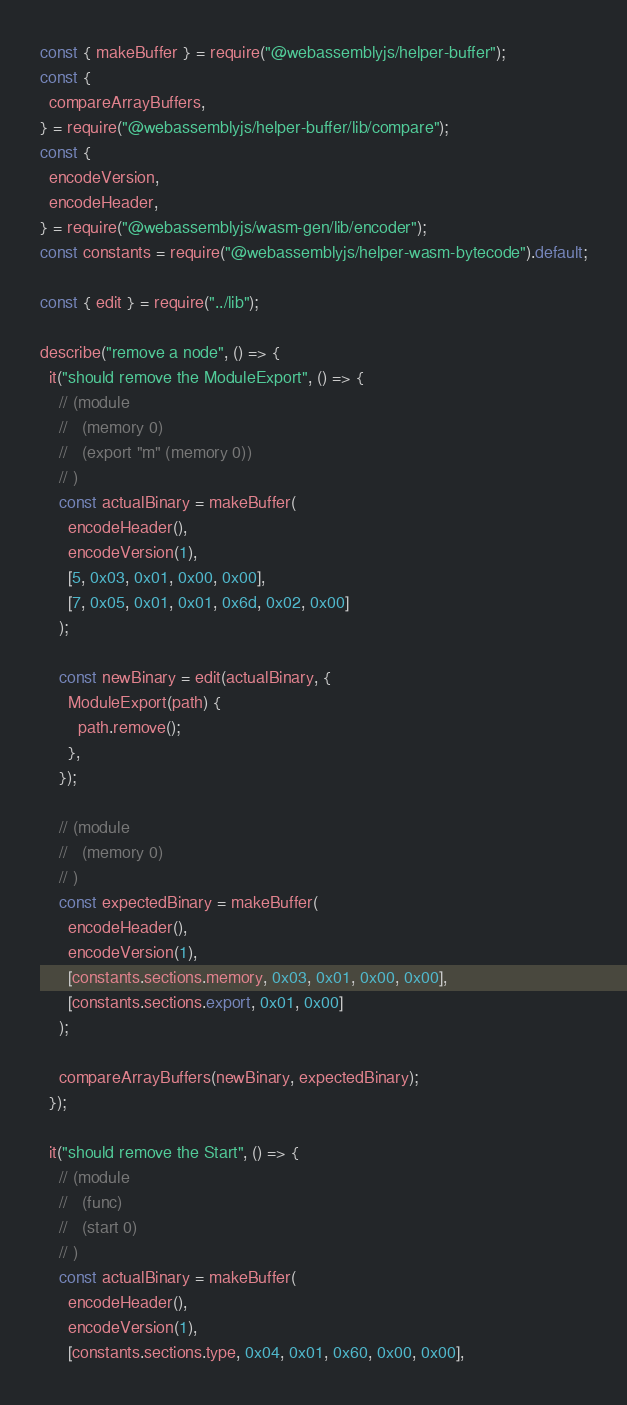<code> <loc_0><loc_0><loc_500><loc_500><_JavaScript_>const { makeBuffer } = require("@webassemblyjs/helper-buffer");
const {
  compareArrayBuffers,
} = require("@webassemblyjs/helper-buffer/lib/compare");
const {
  encodeVersion,
  encodeHeader,
} = require("@webassemblyjs/wasm-gen/lib/encoder");
const constants = require("@webassemblyjs/helper-wasm-bytecode").default;

const { edit } = require("../lib");

describe("remove a node", () => {
  it("should remove the ModuleExport", () => {
    // (module
    //   (memory 0)
    //   (export "m" (memory 0))
    // )
    const actualBinary = makeBuffer(
      encodeHeader(),
      encodeVersion(1),
      [5, 0x03, 0x01, 0x00, 0x00],
      [7, 0x05, 0x01, 0x01, 0x6d, 0x02, 0x00]
    );

    const newBinary = edit(actualBinary, {
      ModuleExport(path) {
        path.remove();
      },
    });

    // (module
    //   (memory 0)
    // )
    const expectedBinary = makeBuffer(
      encodeHeader(),
      encodeVersion(1),
      [constants.sections.memory, 0x03, 0x01, 0x00, 0x00],
      [constants.sections.export, 0x01, 0x00]
    );

    compareArrayBuffers(newBinary, expectedBinary);
  });

  it("should remove the Start", () => {
    // (module
    //   (func)
    //   (start 0)
    // )
    const actualBinary = makeBuffer(
      encodeHeader(),
      encodeVersion(1),
      [constants.sections.type, 0x04, 0x01, 0x60, 0x00, 0x00],</code> 